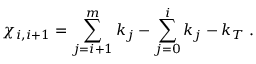<formula> <loc_0><loc_0><loc_500><loc_500>\chi _ { i , i + 1 } = \sum _ { j = i + 1 } ^ { m } k _ { j } - \sum _ { j = 0 } ^ { i } k _ { j } - k _ { T } . \,</formula> 